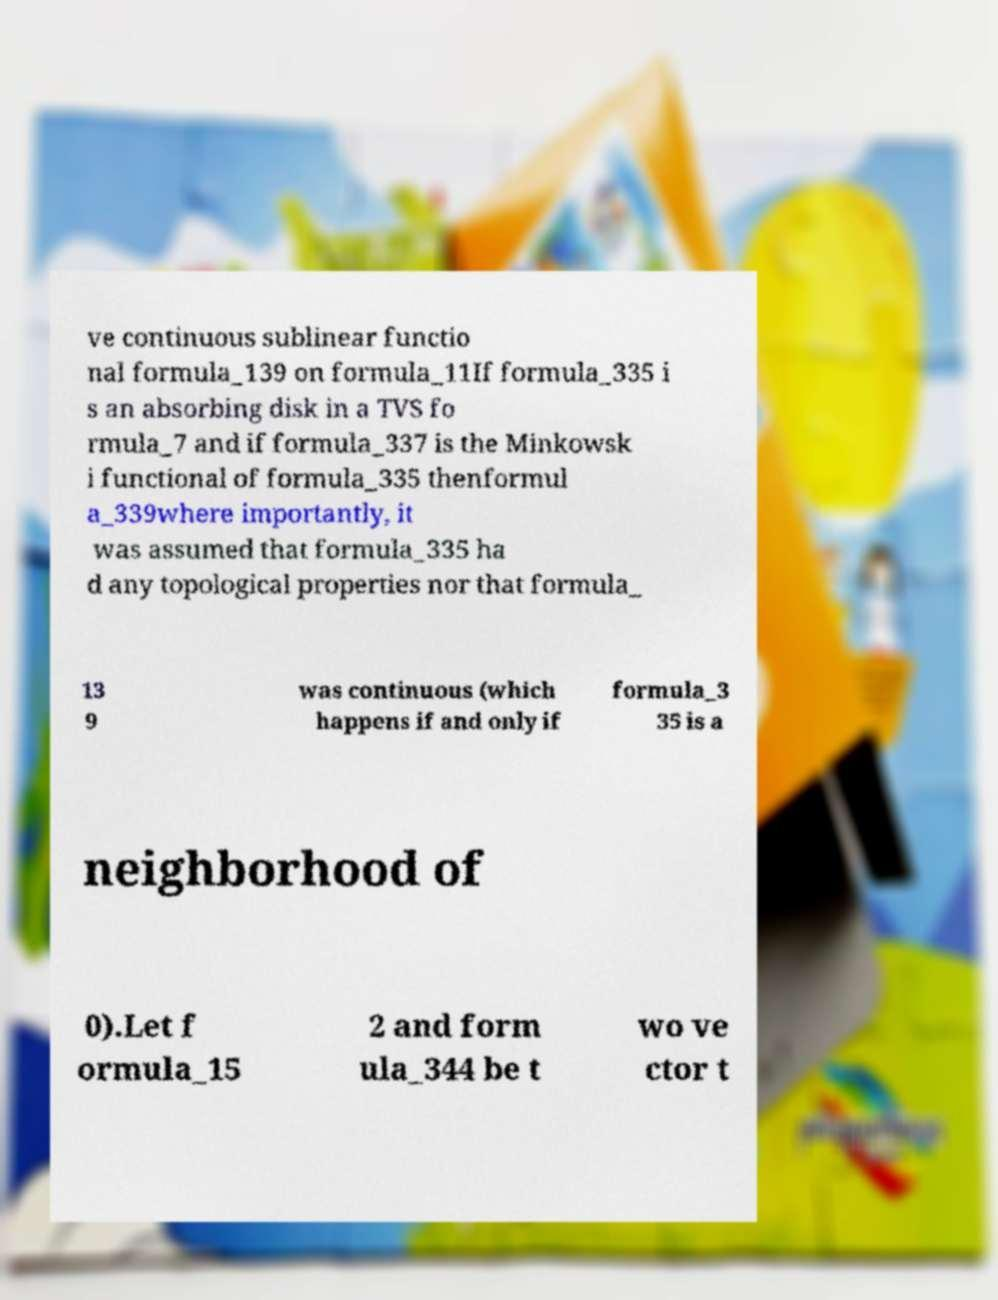Could you assist in decoding the text presented in this image and type it out clearly? ve continuous sublinear functio nal formula_139 on formula_11If formula_335 i s an absorbing disk in a TVS fo rmula_7 and if formula_337 is the Minkowsk i functional of formula_335 thenformul a_339where importantly, it was assumed that formula_335 ha d any topological properties nor that formula_ 13 9 was continuous (which happens if and only if formula_3 35 is a neighborhood of 0).Let f ormula_15 2 and form ula_344 be t wo ve ctor t 